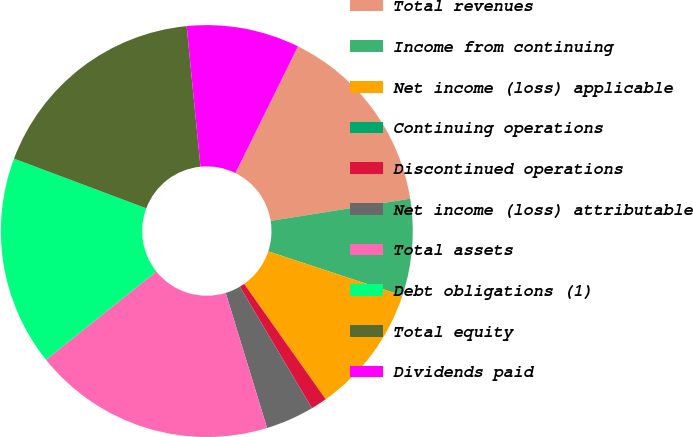<chart> <loc_0><loc_0><loc_500><loc_500><pie_chart><fcel>Total revenues<fcel>Income from continuing<fcel>Net income (loss) applicable<fcel>Continuing operations<fcel>Discontinued operations<fcel>Net income (loss) attributable<fcel>Total assets<fcel>Debt obligations (1)<fcel>Total equity<fcel>Dividends paid<nl><fcel>15.19%<fcel>7.59%<fcel>10.13%<fcel>0.0%<fcel>1.27%<fcel>3.8%<fcel>18.99%<fcel>16.46%<fcel>17.72%<fcel>8.86%<nl></chart> 